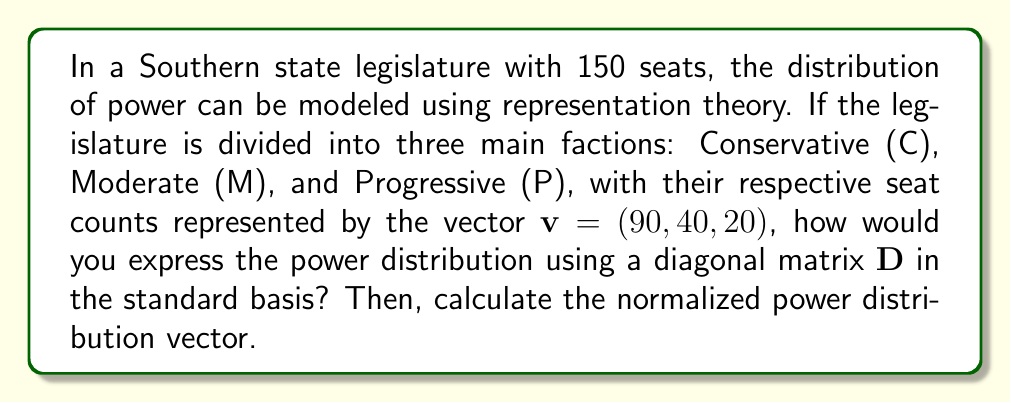Can you solve this math problem? 1. In representation theory, we can model the power distribution using a diagonal matrix $D$ where each entry represents the relative power of a faction.

2. The standard basis for this 3-dimensional space is:
   $e_1 = (1, 0, 0)$ for Conservative
   $e_2 = (0, 1, 0)$ for Moderate
   $e_3 = (0, 0, 1)$ for Progressive

3. To create the diagonal matrix $D$, we use the seat counts as the diagonal entries:

   $$D = \begin{pmatrix}
   90 & 0 & 0 \\
   0 & 40 & 0 \\
   0 & 0 & 20
   \end{pmatrix}$$

4. The power distribution vector is represented by $v = (90, 40, 20)$.

5. To normalize this vector, we divide each entry by the total number of seats:

   $$v_{normalized} = \frac{1}{150} (90, 40, 20)$$

6. Simplifying:
   $$v_{normalized} = (\frac{3}{5}, \frac{4}{15}, \frac{2}{15})$$

This normalized vector represents the proportion of power held by each faction in the legislature.
Answer: $D = \begin{pmatrix}
90 & 0 & 0 \\
0 & 40 & 0 \\
0 & 0 & 20
\end{pmatrix}$, $v_{normalized} = (\frac{3}{5}, \frac{4}{15}, \frac{2}{15})$ 